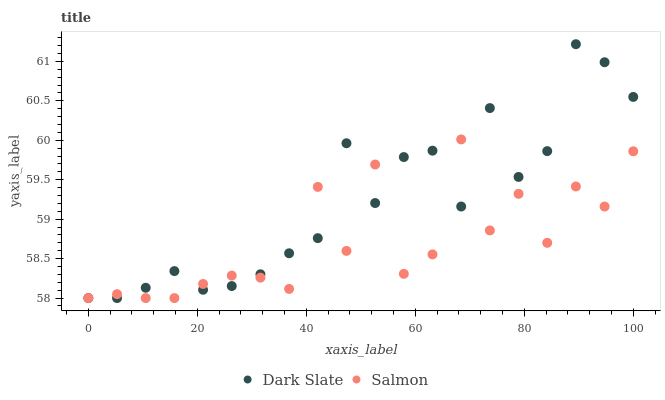Does Salmon have the minimum area under the curve?
Answer yes or no. Yes. Does Dark Slate have the maximum area under the curve?
Answer yes or no. Yes. Does Salmon have the maximum area under the curve?
Answer yes or no. No. Is Dark Slate the smoothest?
Answer yes or no. Yes. Is Salmon the roughest?
Answer yes or no. Yes. Is Salmon the smoothest?
Answer yes or no. No. Does Dark Slate have the lowest value?
Answer yes or no. Yes. Does Dark Slate have the highest value?
Answer yes or no. Yes. Does Salmon have the highest value?
Answer yes or no. No. Does Salmon intersect Dark Slate?
Answer yes or no. Yes. Is Salmon less than Dark Slate?
Answer yes or no. No. Is Salmon greater than Dark Slate?
Answer yes or no. No. 